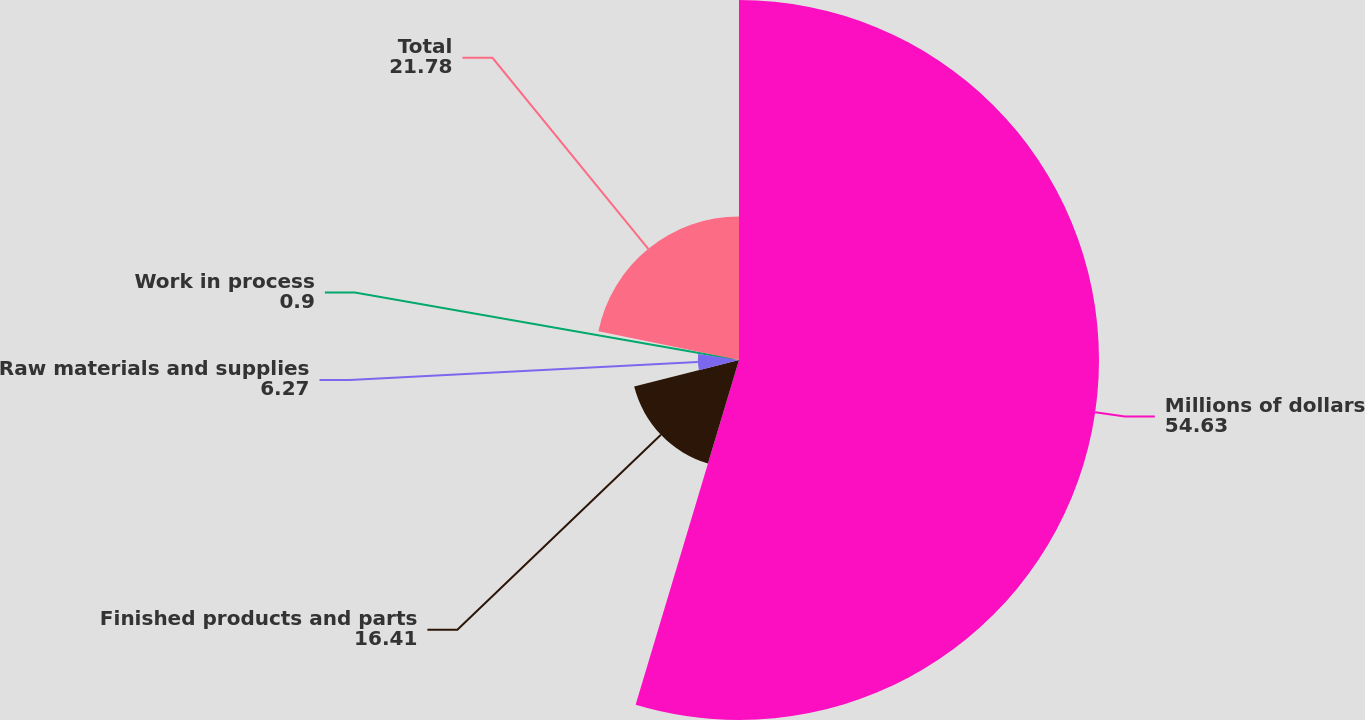<chart> <loc_0><loc_0><loc_500><loc_500><pie_chart><fcel>Millions of dollars<fcel>Finished products and parts<fcel>Raw materials and supplies<fcel>Work in process<fcel>Total<nl><fcel>54.63%<fcel>16.41%<fcel>6.27%<fcel>0.9%<fcel>21.78%<nl></chart> 